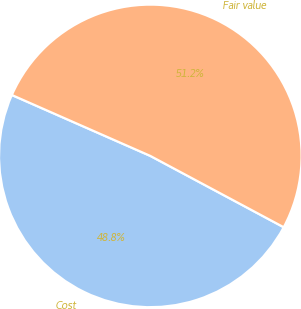Convert chart to OTSL. <chart><loc_0><loc_0><loc_500><loc_500><pie_chart><fcel>Cost<fcel>Fair value<nl><fcel>48.78%<fcel>51.22%<nl></chart> 